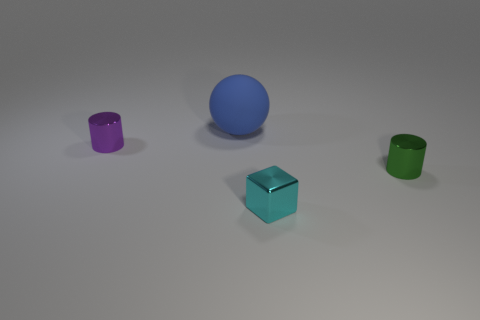Add 3 small rubber cylinders. How many objects exist? 7 Subtract all spheres. How many objects are left? 3 Subtract 0 purple spheres. How many objects are left? 4 Subtract all large objects. Subtract all large purple matte spheres. How many objects are left? 3 Add 2 tiny cyan things. How many tiny cyan things are left? 3 Add 2 blue things. How many blue things exist? 3 